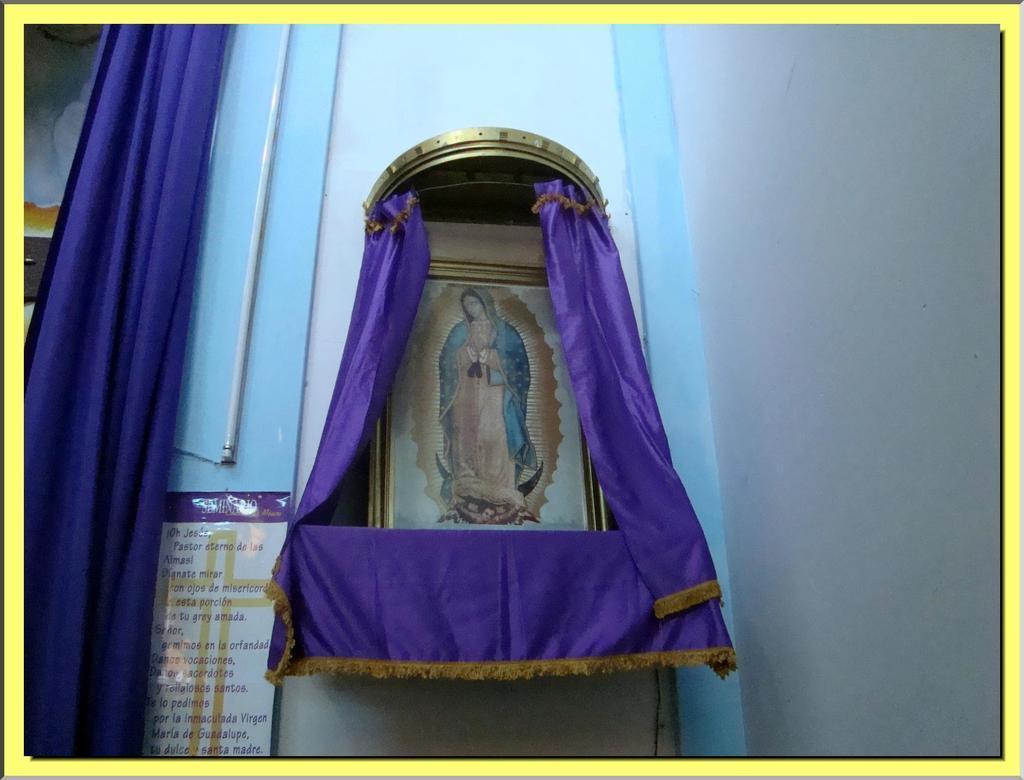Describe this image in one or two sentences. This picture is an edited picture. In this image there is a picture of a person on the frame and there is a frame on the shelf. On the left side of the image there is a board on the wall and there is a text on the board and there is a pipe and curtain on the wall. 